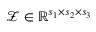Convert formula to latex. <formula><loc_0><loc_0><loc_500><loc_500>\mathcal { Z } \in \mathbb { R } ^ { s _ { 1 } \times s _ { 2 } \times s _ { 3 } }</formula> 